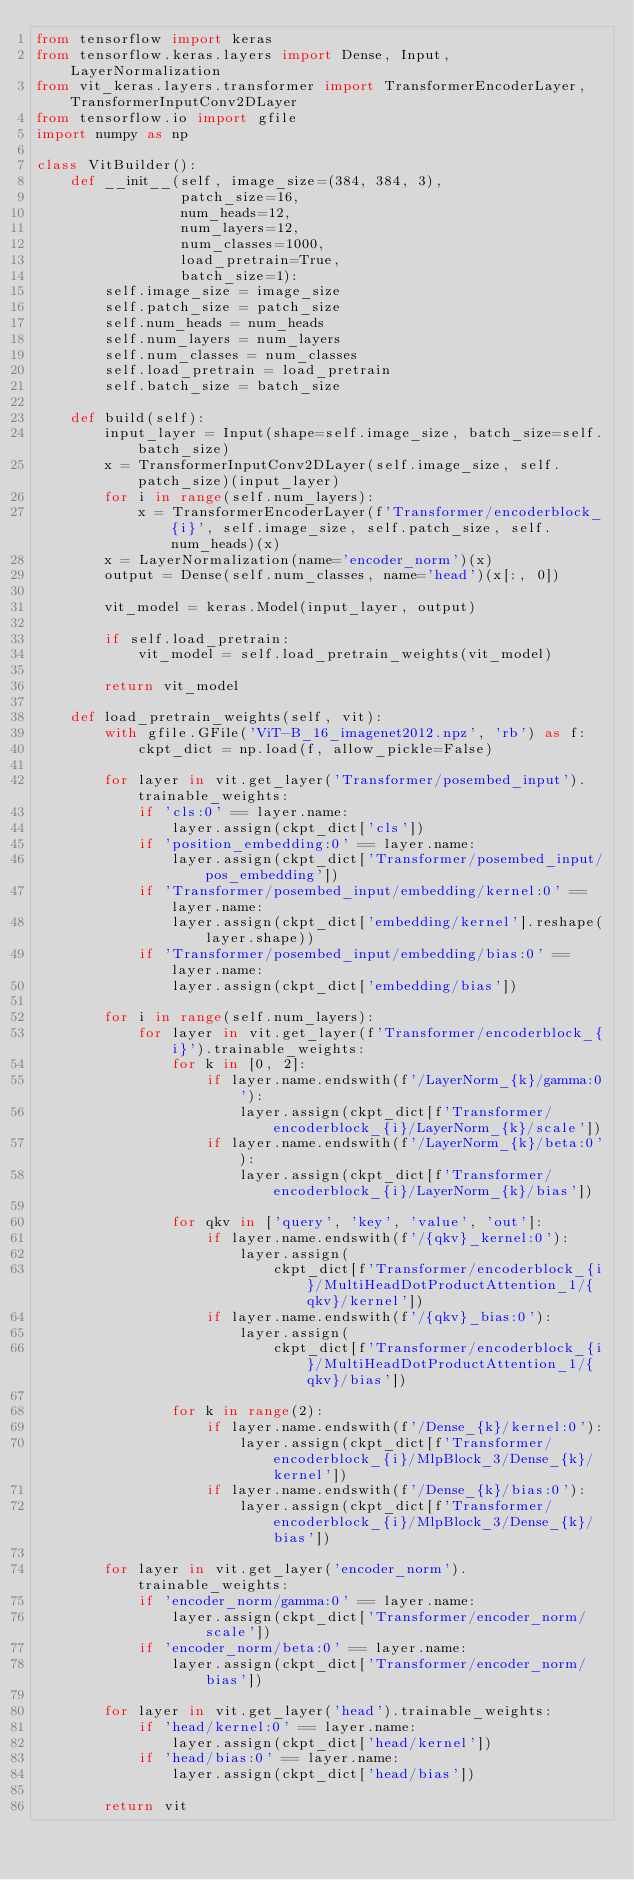<code> <loc_0><loc_0><loc_500><loc_500><_Python_>from tensorflow import keras
from tensorflow.keras.layers import Dense, Input, LayerNormalization
from vit_keras.layers.transformer import TransformerEncoderLayer, TransformerInputConv2DLayer
from tensorflow.io import gfile
import numpy as np

class VitBuilder():
    def __init__(self, image_size=(384, 384, 3),
                 patch_size=16,
                 num_heads=12,
                 num_layers=12,
                 num_classes=1000,
                 load_pretrain=True,
                 batch_size=1):
        self.image_size = image_size
        self.patch_size = patch_size
        self.num_heads = num_heads
        self.num_layers = num_layers
        self.num_classes = num_classes
        self.load_pretrain = load_pretrain
        self.batch_size = batch_size

    def build(self):
        input_layer = Input(shape=self.image_size, batch_size=self.batch_size)
        x = TransformerInputConv2DLayer(self.image_size, self.patch_size)(input_layer)
        for i in range(self.num_layers):
            x = TransformerEncoderLayer(f'Transformer/encoderblock_{i}', self.image_size, self.patch_size, self.num_heads)(x)
        x = LayerNormalization(name='encoder_norm')(x)
        output = Dense(self.num_classes, name='head')(x[:, 0])

        vit_model = keras.Model(input_layer, output)

        if self.load_pretrain:
            vit_model = self.load_pretrain_weights(vit_model)

        return vit_model

    def load_pretrain_weights(self, vit):
        with gfile.GFile('ViT-B_16_imagenet2012.npz', 'rb') as f:
            ckpt_dict = np.load(f, allow_pickle=False)

        for layer in vit.get_layer('Transformer/posembed_input').trainable_weights:
            if 'cls:0' == layer.name:
                layer.assign(ckpt_dict['cls'])
            if 'position_embedding:0' == layer.name:
                layer.assign(ckpt_dict['Transformer/posembed_input/pos_embedding'])
            if 'Transformer/posembed_input/embedding/kernel:0' == layer.name:
                layer.assign(ckpt_dict['embedding/kernel'].reshape(layer.shape))
            if 'Transformer/posembed_input/embedding/bias:0' == layer.name:
                layer.assign(ckpt_dict['embedding/bias'])

        for i in range(self.num_layers):
            for layer in vit.get_layer(f'Transformer/encoderblock_{i}').trainable_weights:
                for k in [0, 2]:
                    if layer.name.endswith(f'/LayerNorm_{k}/gamma:0'):
                        layer.assign(ckpt_dict[f'Transformer/encoderblock_{i}/LayerNorm_{k}/scale'])
                    if layer.name.endswith(f'/LayerNorm_{k}/beta:0'):
                        layer.assign(ckpt_dict[f'Transformer/encoderblock_{i}/LayerNorm_{k}/bias'])

                for qkv in ['query', 'key', 'value', 'out']:
                    if layer.name.endswith(f'/{qkv}_kernel:0'):
                        layer.assign(
                            ckpt_dict[f'Transformer/encoderblock_{i}/MultiHeadDotProductAttention_1/{qkv}/kernel'])
                    if layer.name.endswith(f'/{qkv}_bias:0'):
                        layer.assign(
                            ckpt_dict[f'Transformer/encoderblock_{i}/MultiHeadDotProductAttention_1/{qkv}/bias'])

                for k in range(2):
                    if layer.name.endswith(f'/Dense_{k}/kernel:0'):
                        layer.assign(ckpt_dict[f'Transformer/encoderblock_{i}/MlpBlock_3/Dense_{k}/kernel'])
                    if layer.name.endswith(f'/Dense_{k}/bias:0'):
                        layer.assign(ckpt_dict[f'Transformer/encoderblock_{i}/MlpBlock_3/Dense_{k}/bias'])

        for layer in vit.get_layer('encoder_norm').trainable_weights:
            if 'encoder_norm/gamma:0' == layer.name:
                layer.assign(ckpt_dict['Transformer/encoder_norm/scale'])
            if 'encoder_norm/beta:0' == layer.name:
                layer.assign(ckpt_dict['Transformer/encoder_norm/bias'])

        for layer in vit.get_layer('head').trainable_weights:
            if 'head/kernel:0' == layer.name:
                layer.assign(ckpt_dict['head/kernel'])
            if 'head/bias:0' == layer.name:
                layer.assign(ckpt_dict['head/bias'])

        return vit
</code> 